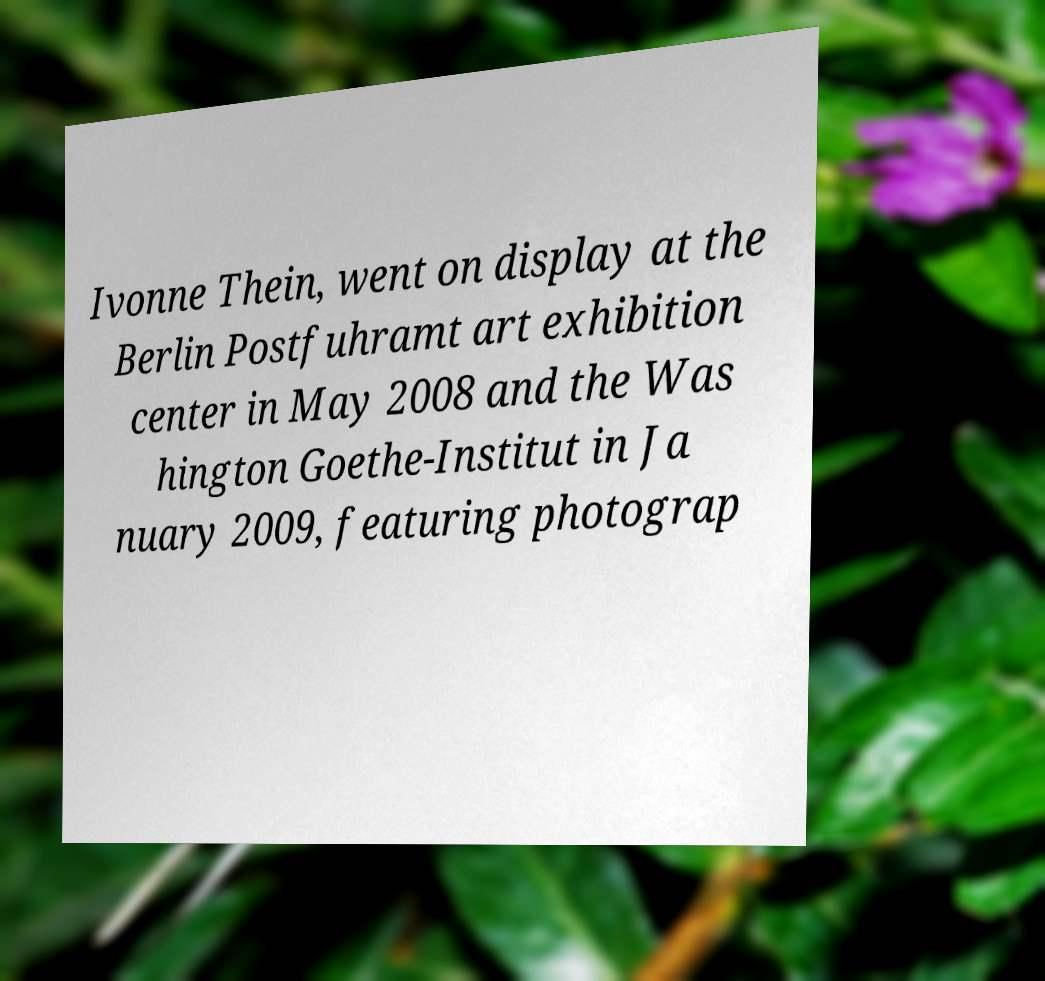For documentation purposes, I need the text within this image transcribed. Could you provide that? Ivonne Thein, went on display at the Berlin Postfuhramt art exhibition center in May 2008 and the Was hington Goethe-Institut in Ja nuary 2009, featuring photograp 